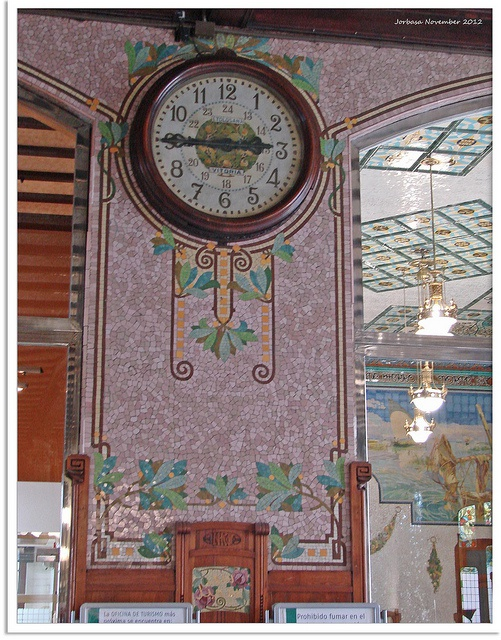Describe the objects in this image and their specific colors. I can see a clock in white, black, gray, and maroon tones in this image. 